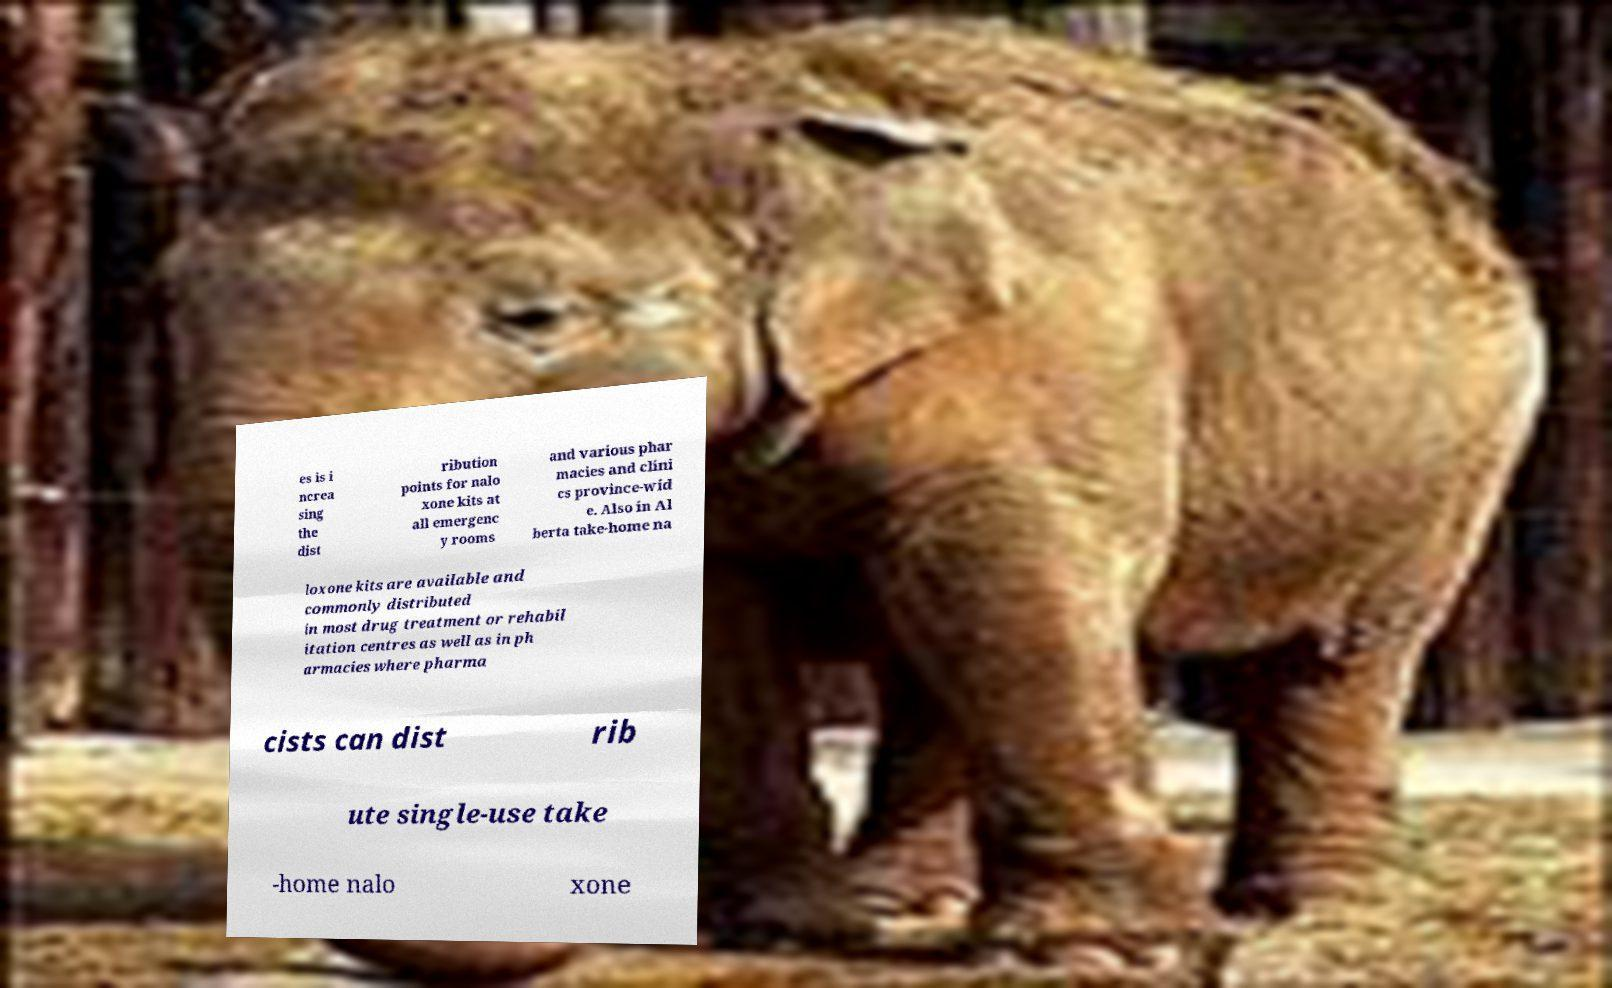Could you assist in decoding the text presented in this image and type it out clearly? es is i ncrea sing the dist ribution points for nalo xone kits at all emergenc y rooms and various phar macies and clini cs province-wid e. Also in Al berta take-home na loxone kits are available and commonly distributed in most drug treatment or rehabil itation centres as well as in ph armacies where pharma cists can dist rib ute single-use take -home nalo xone 